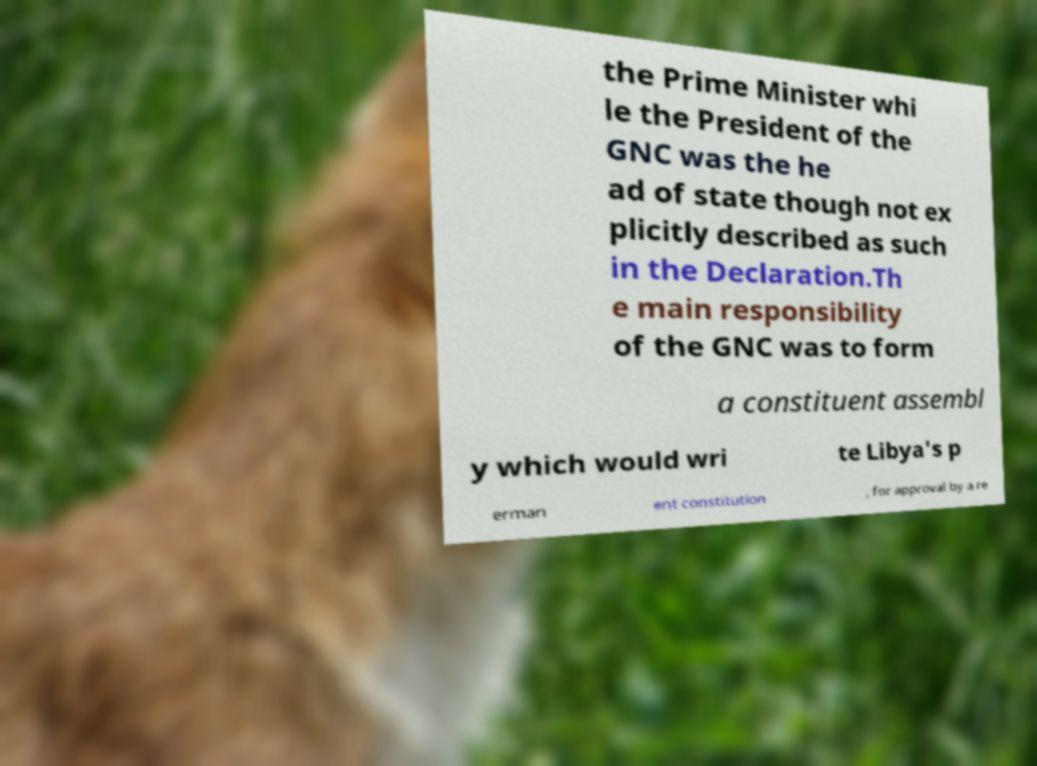What messages or text are displayed in this image? I need them in a readable, typed format. the Prime Minister whi le the President of the GNC was the he ad of state though not ex plicitly described as such in the Declaration.Th e main responsibility of the GNC was to form a constituent assembl y which would wri te Libya's p erman ent constitution , for approval by a re 